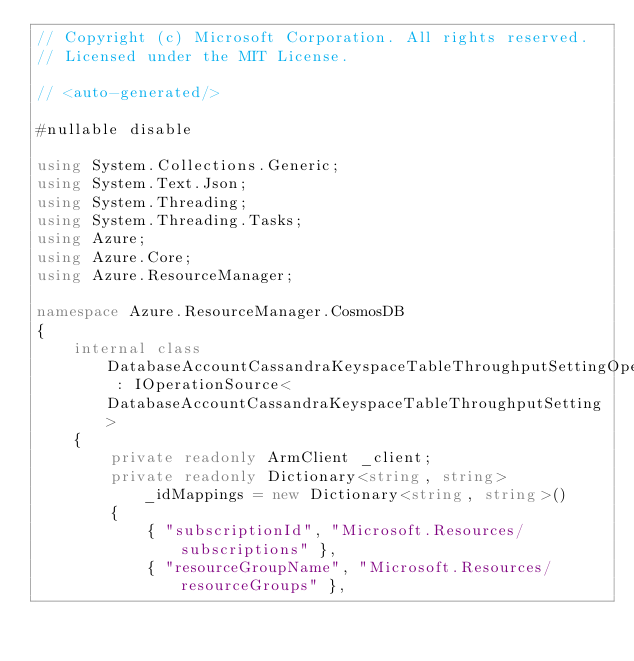<code> <loc_0><loc_0><loc_500><loc_500><_C#_>// Copyright (c) Microsoft Corporation. All rights reserved.
// Licensed under the MIT License.

// <auto-generated/>

#nullable disable

using System.Collections.Generic;
using System.Text.Json;
using System.Threading;
using System.Threading.Tasks;
using Azure;
using Azure.Core;
using Azure.ResourceManager;

namespace Azure.ResourceManager.CosmosDB
{
    internal class DatabaseAccountCassandraKeyspaceTableThroughputSettingOperationSource : IOperationSource<DatabaseAccountCassandraKeyspaceTableThroughputSetting>
    {
        private readonly ArmClient _client;
        private readonly Dictionary<string, string> _idMappings = new Dictionary<string, string>()
        {
            { "subscriptionId", "Microsoft.Resources/subscriptions" },
            { "resourceGroupName", "Microsoft.Resources/resourceGroups" },</code> 